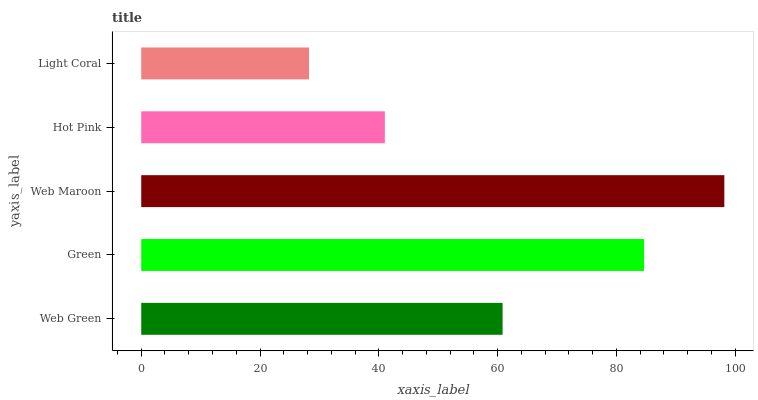Is Light Coral the minimum?
Answer yes or no. Yes. Is Web Maroon the maximum?
Answer yes or no. Yes. Is Green the minimum?
Answer yes or no. No. Is Green the maximum?
Answer yes or no. No. Is Green greater than Web Green?
Answer yes or no. Yes. Is Web Green less than Green?
Answer yes or no. Yes. Is Web Green greater than Green?
Answer yes or no. No. Is Green less than Web Green?
Answer yes or no. No. Is Web Green the high median?
Answer yes or no. Yes. Is Web Green the low median?
Answer yes or no. Yes. Is Web Maroon the high median?
Answer yes or no. No. Is Green the low median?
Answer yes or no. No. 